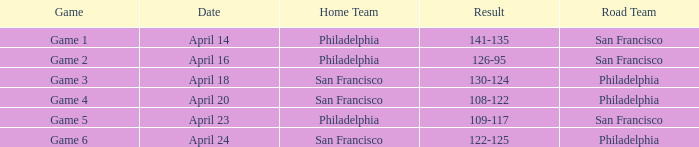Which games had Philadelphia as home team? Game 1, Game 2, Game 5. 